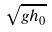<formula> <loc_0><loc_0><loc_500><loc_500>\sqrt { g h _ { 0 } }</formula> 